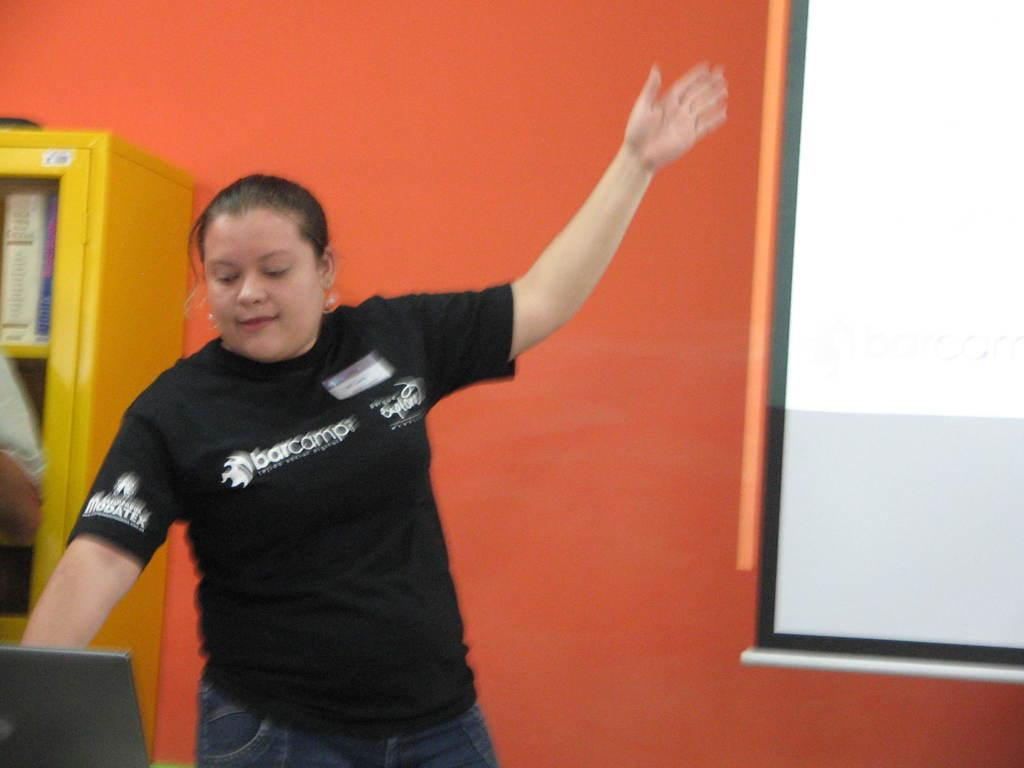What is the main subject in the image? There is a woman standing in the image. Where is the woman standing? The woman is standing on the floor. What can be seen behind the woman? There is a projector screen in the image. What other objects are present in the image? There is a cupboard and a wall in the image. Can you see the coast in the image? No, there is no coast visible in the image. Is there a recess in the wall where the woman is standing? There is no mention of a recess in the wall in the provided facts, so we cannot determine its presence from the image. 